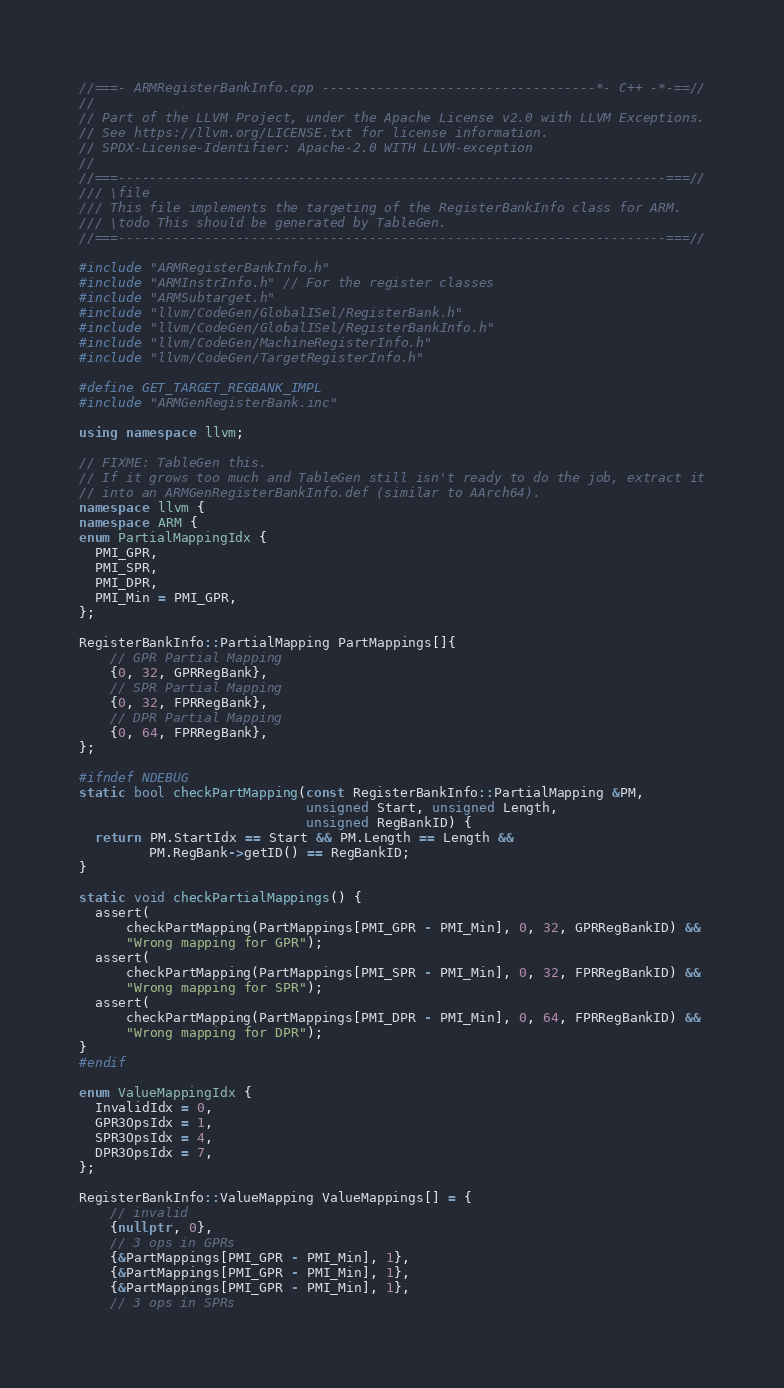<code> <loc_0><loc_0><loc_500><loc_500><_C++_>//===- ARMRegisterBankInfo.cpp -----------------------------------*- C++ -*-==//
//
// Part of the LLVM Project, under the Apache License v2.0 with LLVM Exceptions.
// See https://llvm.org/LICENSE.txt for license information.
// SPDX-License-Identifier: Apache-2.0 WITH LLVM-exception
//
//===----------------------------------------------------------------------===//
/// \file
/// This file implements the targeting of the RegisterBankInfo class for ARM.
/// \todo This should be generated by TableGen.
//===----------------------------------------------------------------------===//

#include "ARMRegisterBankInfo.h"
#include "ARMInstrInfo.h" // For the register classes
#include "ARMSubtarget.h"
#include "llvm/CodeGen/GlobalISel/RegisterBank.h"
#include "llvm/CodeGen/GlobalISel/RegisterBankInfo.h"
#include "llvm/CodeGen/MachineRegisterInfo.h"
#include "llvm/CodeGen/TargetRegisterInfo.h"

#define GET_TARGET_REGBANK_IMPL
#include "ARMGenRegisterBank.inc"

using namespace llvm;

// FIXME: TableGen this.
// If it grows too much and TableGen still isn't ready to do the job, extract it
// into an ARMGenRegisterBankInfo.def (similar to AArch64).
namespace llvm {
namespace ARM {
enum PartialMappingIdx {
  PMI_GPR,
  PMI_SPR,
  PMI_DPR,
  PMI_Min = PMI_GPR,
};

RegisterBankInfo::PartialMapping PartMappings[]{
    // GPR Partial Mapping
    {0, 32, GPRRegBank},
    // SPR Partial Mapping
    {0, 32, FPRRegBank},
    // DPR Partial Mapping
    {0, 64, FPRRegBank},
};

#ifndef NDEBUG
static bool checkPartMapping(const RegisterBankInfo::PartialMapping &PM,
                             unsigned Start, unsigned Length,
                             unsigned RegBankID) {
  return PM.StartIdx == Start && PM.Length == Length &&
         PM.RegBank->getID() == RegBankID;
}

static void checkPartialMappings() {
  assert(
      checkPartMapping(PartMappings[PMI_GPR - PMI_Min], 0, 32, GPRRegBankID) &&
      "Wrong mapping for GPR");
  assert(
      checkPartMapping(PartMappings[PMI_SPR - PMI_Min], 0, 32, FPRRegBankID) &&
      "Wrong mapping for SPR");
  assert(
      checkPartMapping(PartMappings[PMI_DPR - PMI_Min], 0, 64, FPRRegBankID) &&
      "Wrong mapping for DPR");
}
#endif

enum ValueMappingIdx {
  InvalidIdx = 0,
  GPR3OpsIdx = 1,
  SPR3OpsIdx = 4,
  DPR3OpsIdx = 7,
};

RegisterBankInfo::ValueMapping ValueMappings[] = {
    // invalid
    {nullptr, 0},
    // 3 ops in GPRs
    {&PartMappings[PMI_GPR - PMI_Min], 1},
    {&PartMappings[PMI_GPR - PMI_Min], 1},
    {&PartMappings[PMI_GPR - PMI_Min], 1},
    // 3 ops in SPRs</code> 